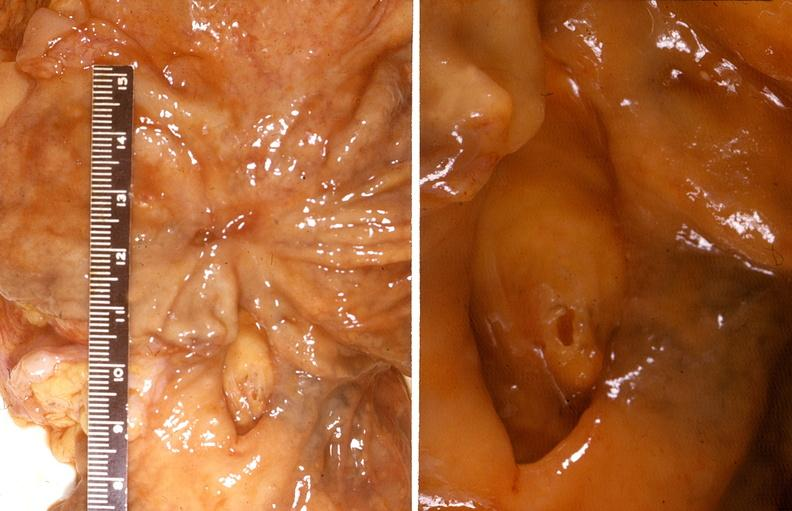does beckwith-wiedemann syndrome show stomach, healed peptic ulcer and bleeding duodenal ulcer?
Answer the question using a single word or phrase. No 